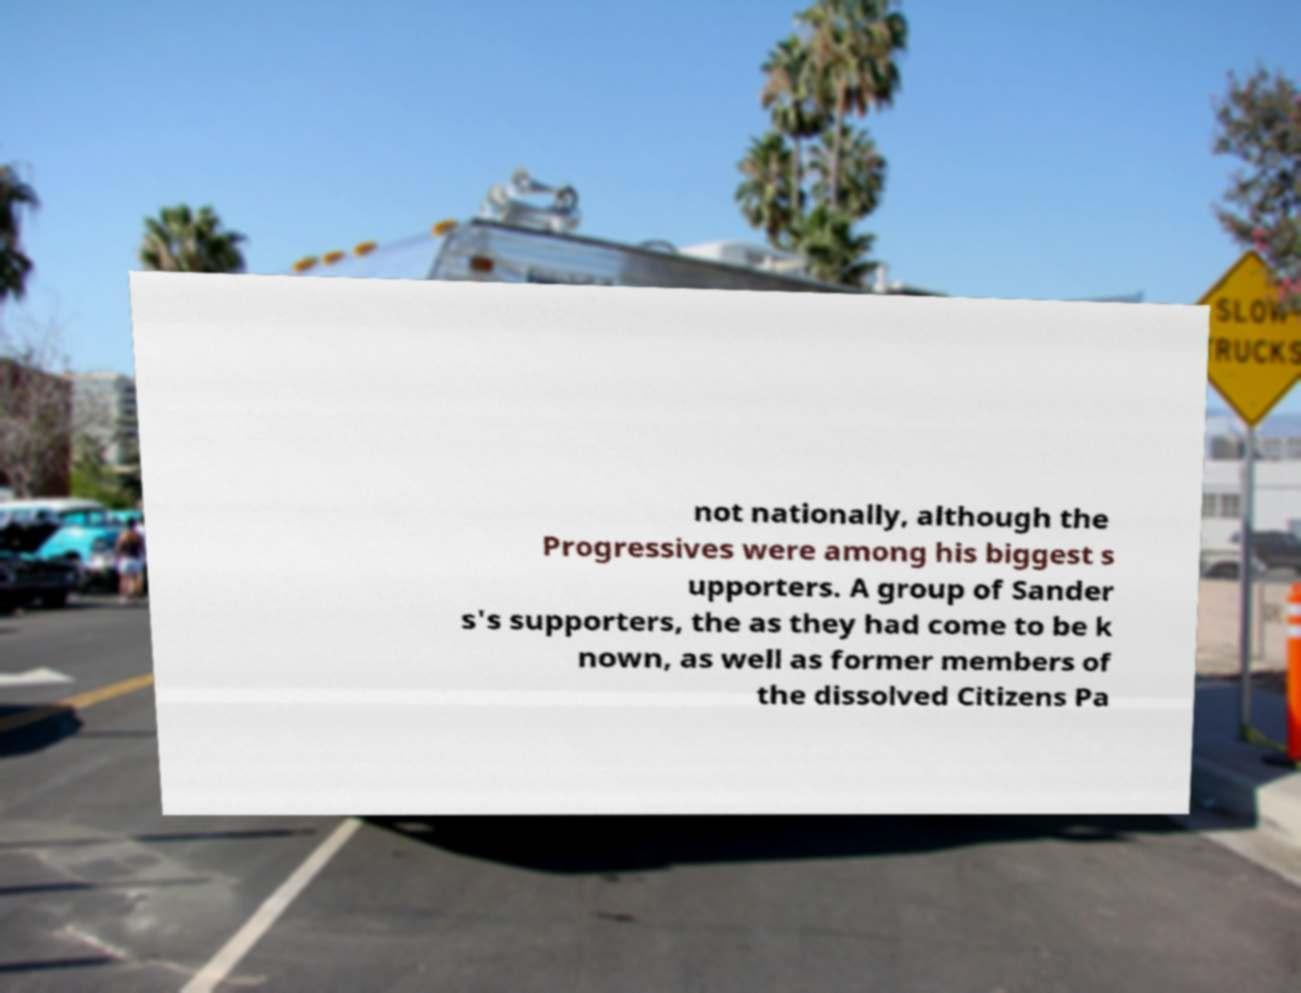Can you read and provide the text displayed in the image?This photo seems to have some interesting text. Can you extract and type it out for me? not nationally, although the Progressives were among his biggest s upporters. A group of Sander s's supporters, the as they had come to be k nown, as well as former members of the dissolved Citizens Pa 